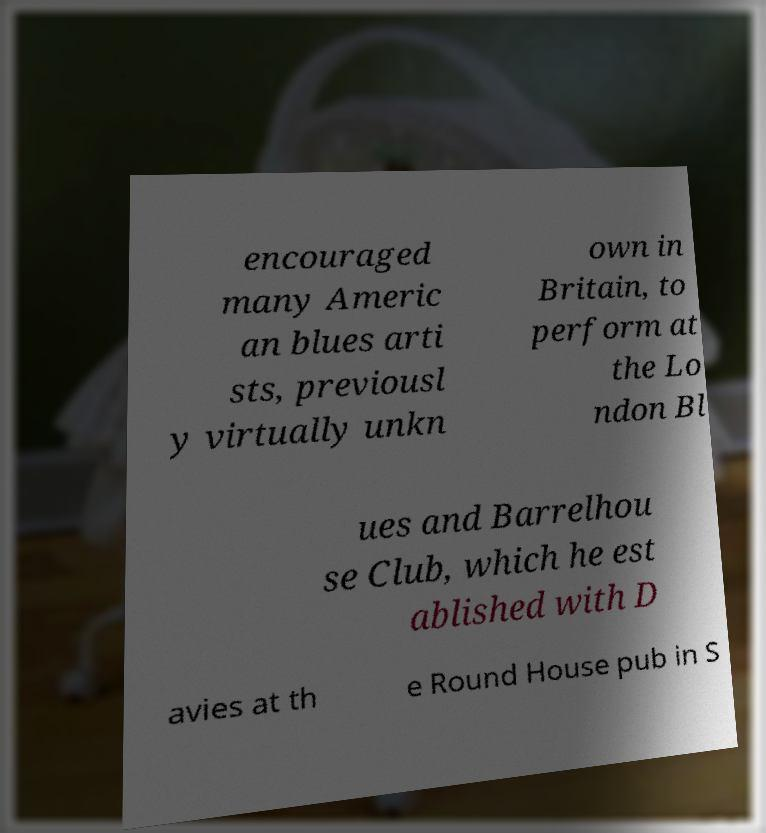Please identify and transcribe the text found in this image. encouraged many Americ an blues arti sts, previousl y virtually unkn own in Britain, to perform at the Lo ndon Bl ues and Barrelhou se Club, which he est ablished with D avies at th e Round House pub in S 